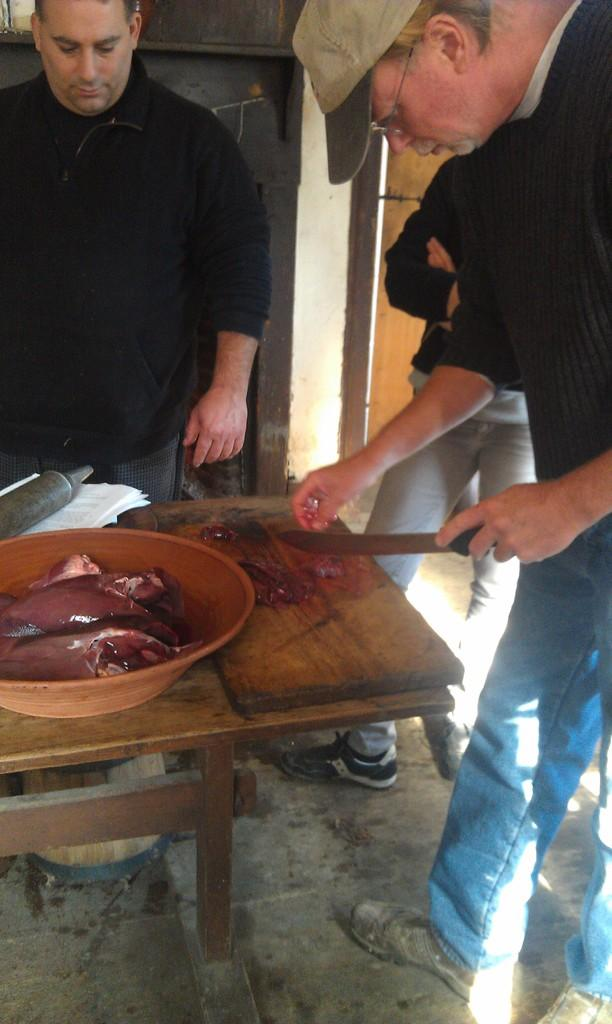What object is the person holding in the image? The person is holding a knife in the image. What is on the table in the image? There is a bowl and papers on the table in the image. What is on the bowl on the table? The provided facts do not specify what is in the bowl. What is on the table that is not the bowl or papers? There is flesh on the table in the image. How many people are visible in the image? There are people visible in the image. How many babies are visible in the image? There are no babies visible in the image. What type of calculator is being used by the group in the image? There is no group or calculator present in the image. 